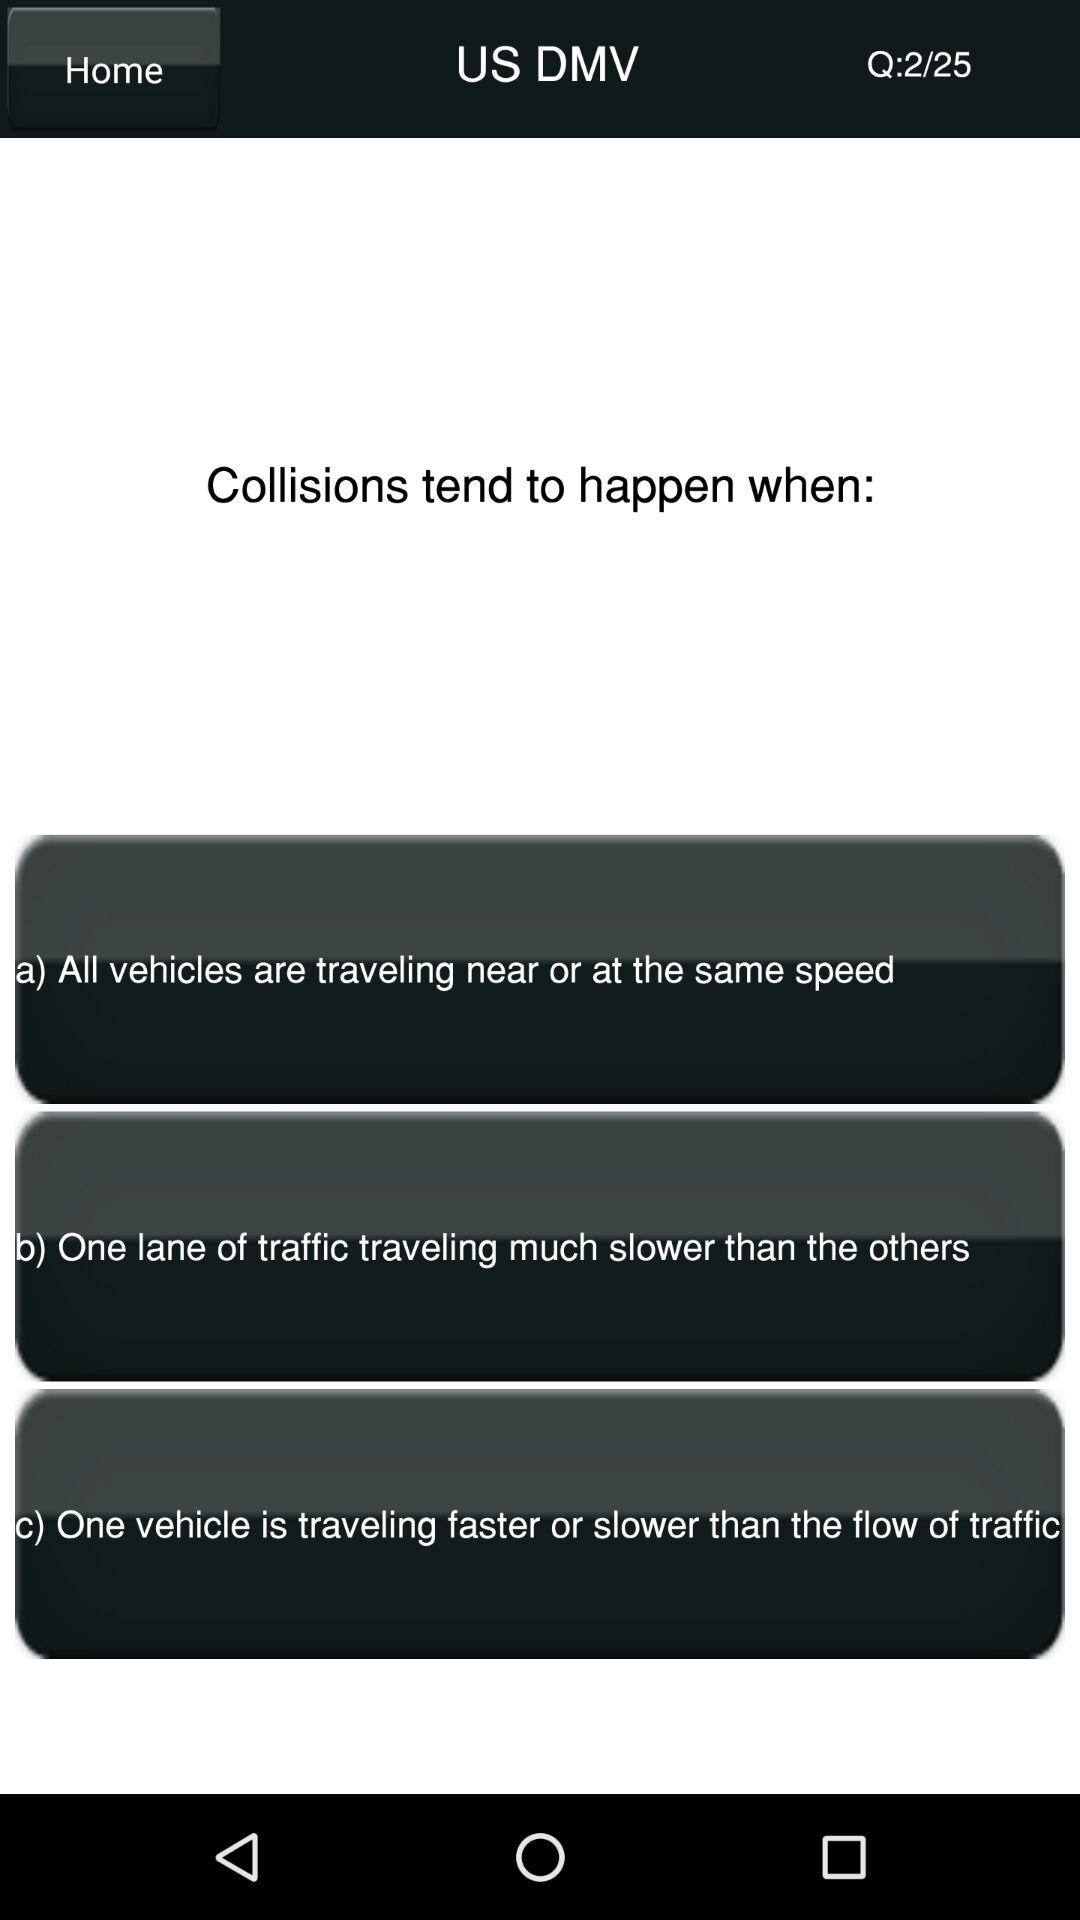Which question number am I on? You are on question number 2. 